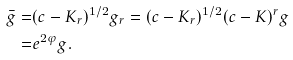Convert formula to latex. <formula><loc_0><loc_0><loc_500><loc_500>\bar { g } = & ( c - K _ { r } ) ^ { 1 / 2 } g _ { r } = ( c - K _ { r } ) ^ { 1 / 2 } ( c - K ) ^ { r } g \\ = & e ^ { 2 \varphi } g .</formula> 